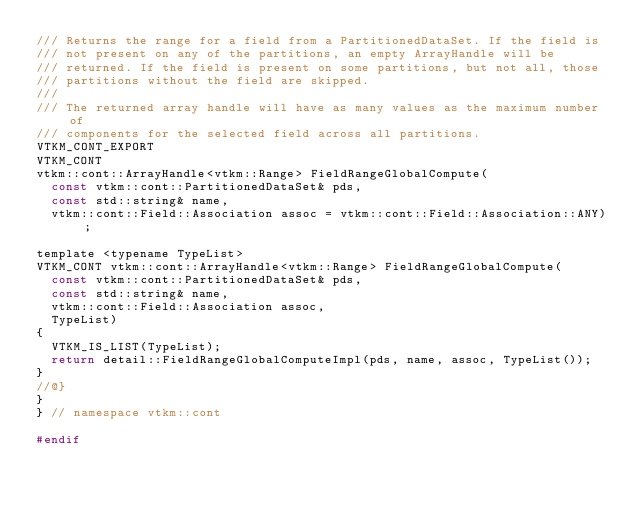Convert code to text. <code><loc_0><loc_0><loc_500><loc_500><_C_>/// Returns the range for a field from a PartitionedDataSet. If the field is
/// not present on any of the partitions, an empty ArrayHandle will be
/// returned. If the field is present on some partitions, but not all, those
/// partitions without the field are skipped.
///
/// The returned array handle will have as many values as the maximum number of
/// components for the selected field across all partitions.
VTKM_CONT_EXPORT
VTKM_CONT
vtkm::cont::ArrayHandle<vtkm::Range> FieldRangeGlobalCompute(
  const vtkm::cont::PartitionedDataSet& pds,
  const std::string& name,
  vtkm::cont::Field::Association assoc = vtkm::cont::Field::Association::ANY);

template <typename TypeList>
VTKM_CONT vtkm::cont::ArrayHandle<vtkm::Range> FieldRangeGlobalCompute(
  const vtkm::cont::PartitionedDataSet& pds,
  const std::string& name,
  vtkm::cont::Field::Association assoc,
  TypeList)
{
  VTKM_IS_LIST(TypeList);
  return detail::FieldRangeGlobalComputeImpl(pds, name, assoc, TypeList());
}
//@}
}
} // namespace vtkm::cont

#endif
</code> 